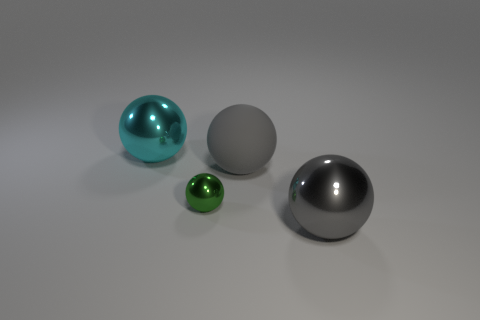Subtract 1 balls. How many balls are left? 3 Add 4 big gray rubber objects. How many objects exist? 8 Add 4 large metallic objects. How many large metallic objects exist? 6 Subtract 0 red blocks. How many objects are left? 4 Subtract all tiny green metal cubes. Subtract all spheres. How many objects are left? 0 Add 1 green shiny spheres. How many green shiny spheres are left? 2 